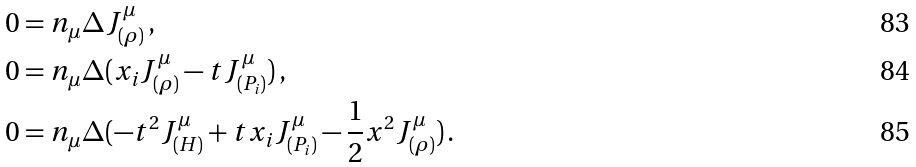Convert formula to latex. <formula><loc_0><loc_0><loc_500><loc_500>0 & = n _ { \mu } \Delta J ^ { \mu } _ { ( \rho ) } \, , \\ 0 & = n _ { \mu } \Delta ( x _ { i } J _ { ( \rho ) } ^ { \mu } - t J _ { ( P _ { i } ) } ^ { \mu } ) \, , \\ 0 & = n _ { \mu } \Delta ( - t ^ { 2 } J _ { ( H ) } ^ { \mu } + t x _ { i } J _ { ( P _ { i } ) } ^ { \mu } - \frac { 1 } { 2 } x ^ { 2 } J _ { ( \rho ) } ^ { \mu } ) \, .</formula> 